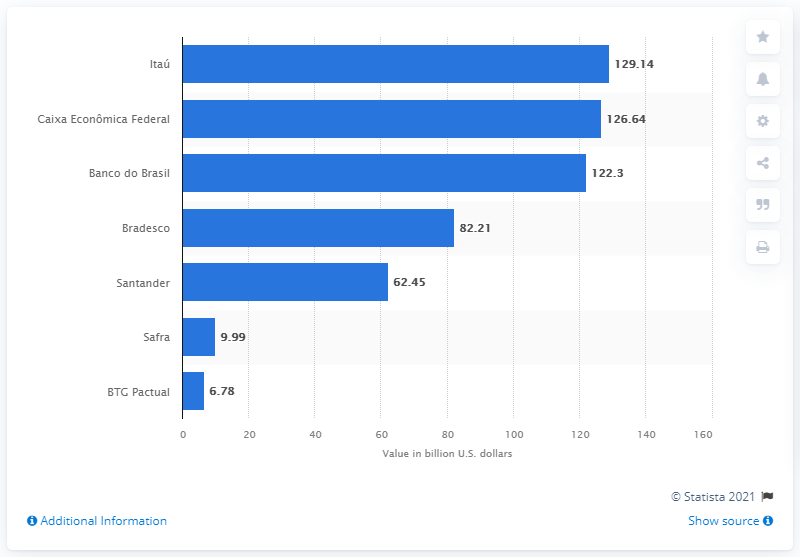What information does this image provide apart from the deposit values? This image provides a visual comparison of the deposit volumes across major Brazilian banks. Additionally, it shows the scale of these values in billion U.S. dollars, and the source of the information (Statista 2021) is cited at the bottom right. 